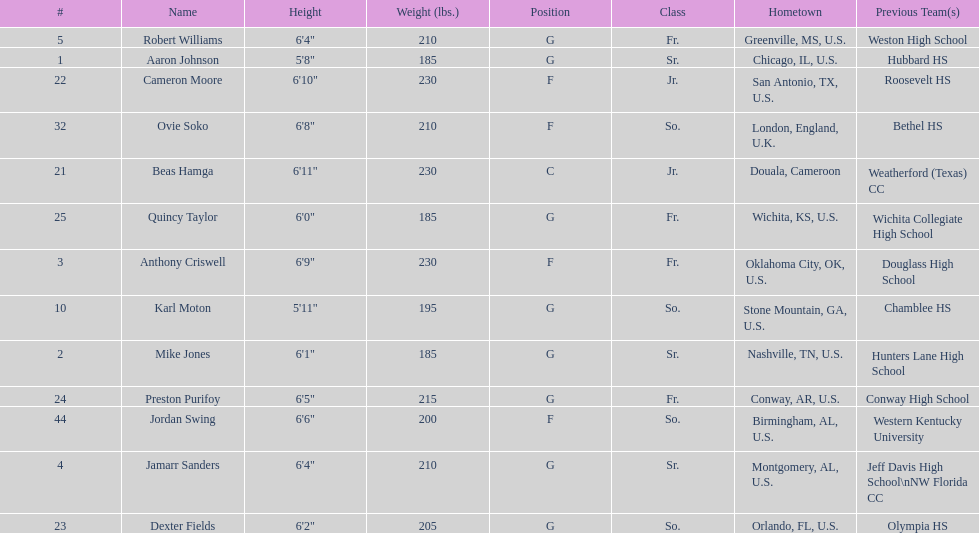Which team member has the greatest height? Beas Hamga. 